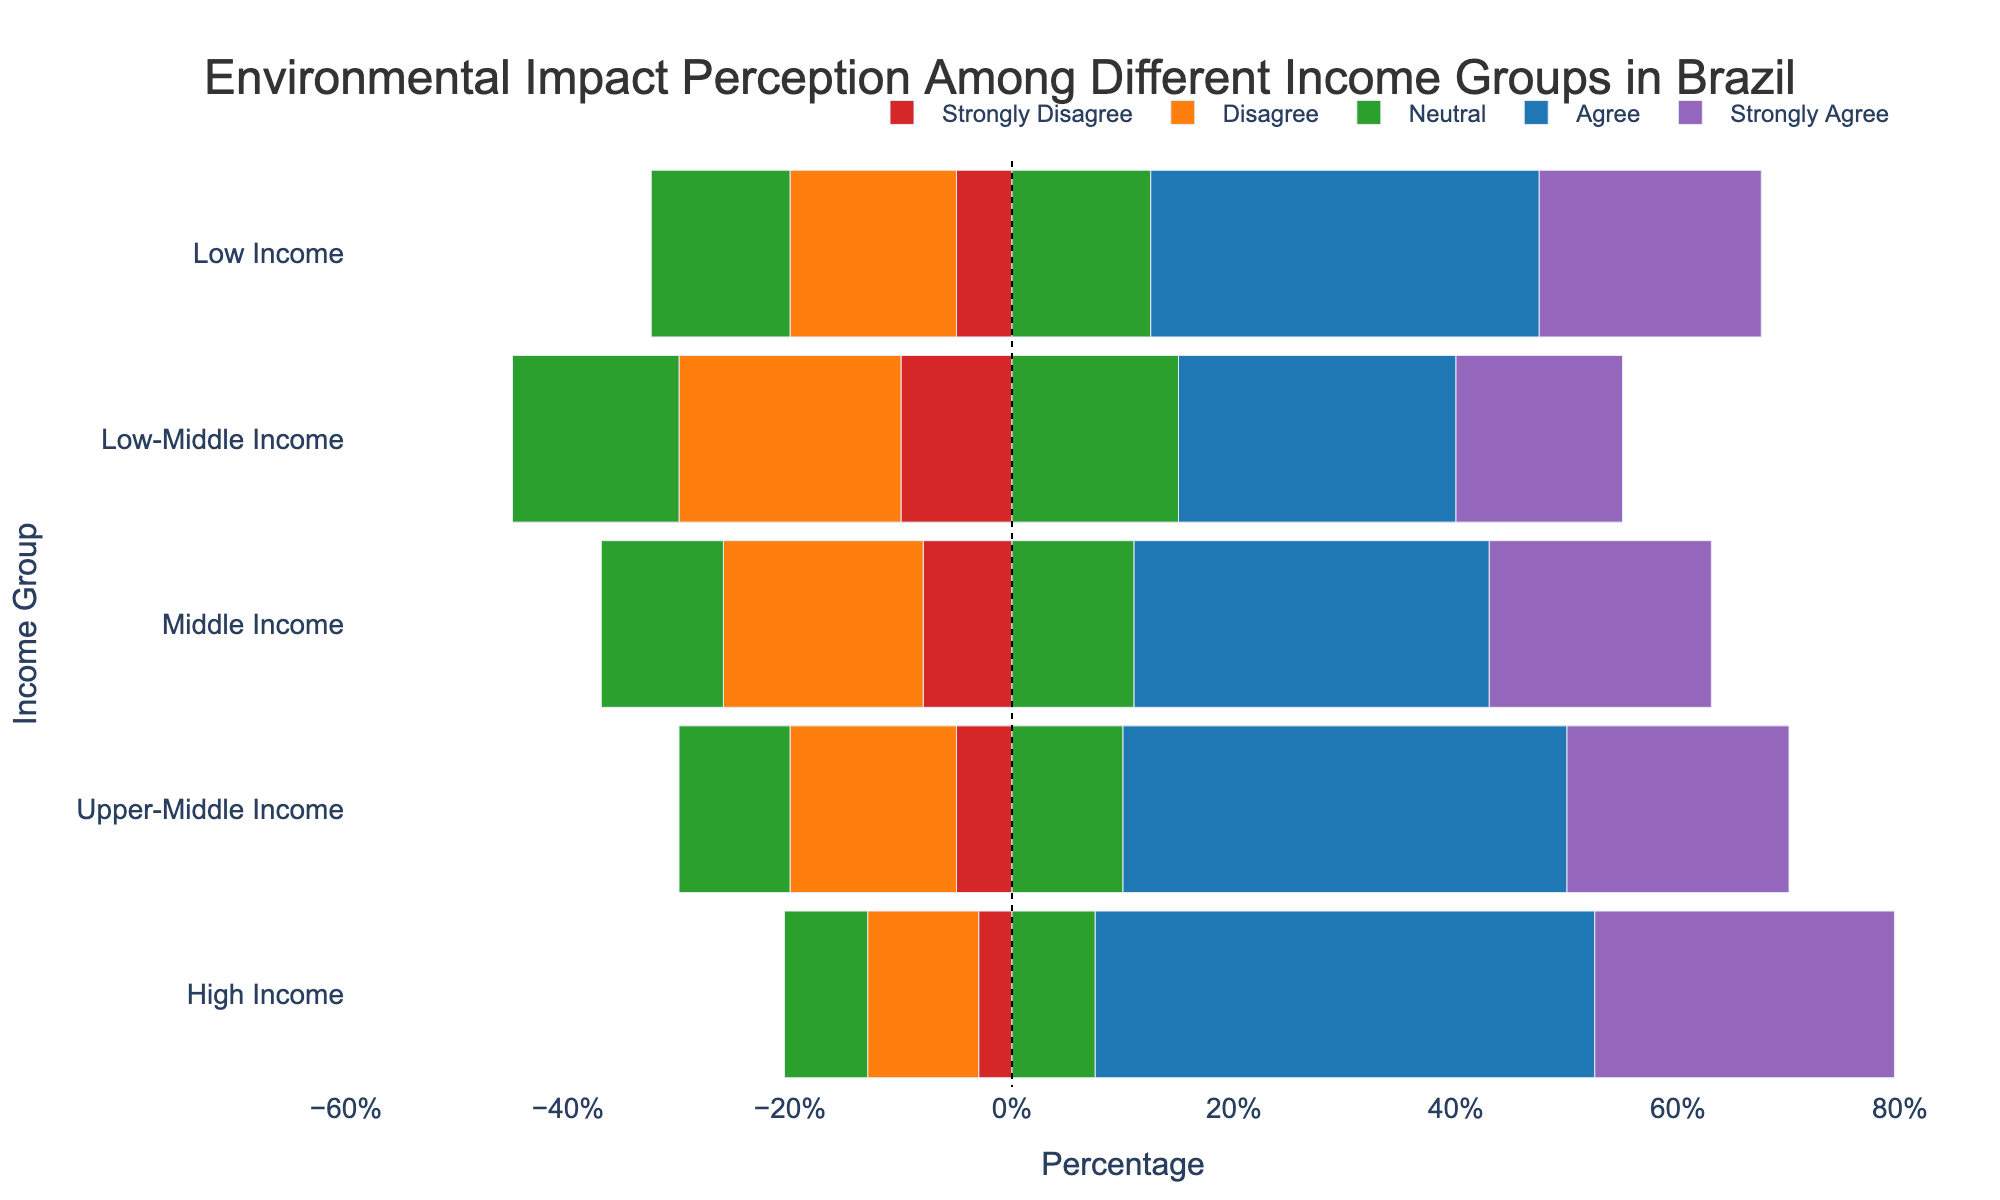Which income group has the highest percentage of people who 'Strongly Agree' on environmental impact? To determine this, look for the group with the longest bar segment in the 'Strongly Agree' section (blue color). The High Income group shows the longest 'Strongly Agree' bar.
Answer: High Income How many more people in the High Income group 'Agree' with the environmental impact compared to the Low Income group? Look at the length of the 'Agree' segments (light blue color) for both groups. The High Income group has 45% in 'Agree', whereas the Low Income group has 35%. Subtract 35% from 45% to get 10%.
Answer: 10% What is the total percentage of Low-Middle Income group people who either 'Agree' or 'Strongly Agree' on environmental impact? Sum the 'Agree' and 'Strongly Agree' percentages for the Low-Middle Income group. They are 25% and 15%, respectively. Adding them gives 25% + 15% = 40%.
Answer: 40% Which income group expresses the most disagreement (combination of 'Strongly Disagree' and 'Disagree')? Combine the 'Strongly Disagree' and 'Disagree' segments (red and orange colors) for each income group and compare them. The Low-Middle Income group has the highest total disagreement (10% + 20% = 30%).
Answer: Low-Middle Income How does the percentage of neutral responses in the Middle Income group compare to that in the Upper-Middle Income group? Look at the length of the 'Neutral' segments (green color) for both groups. Middle Income has 22% and Upper-Middle Income has 20%. Therefore, the Middle Income group has 2% more neutral responses than the Upper-Middle Income group.
Answer: Middle Income has 2% more neutral responses Which income group shows the highest combined percentage in the two top positive categories (‘Agree’ and ‘Strongly Agree’)? Combine the 'Agree' and 'Strongly Agree' segments for each group and find the maximum. The High Income group has the highest combined percentage with (45% + 27% = 72%).
Answer: High Income What is the combined percentage of negative and positive responses for Upper-Middle Income group? Sum the 'Strongly Disagree' and 'Disagree' percentages (negative) and 'Agree' and 'Strongly Agree' percentages (positive). The negative responses are 5% + 15% = 20%, and positive responses are 40% + 20% = 60%. Combined percentage is 20% + 60% = 80%.
Answer: 80% Which income group has the smallest proportion of strongly negative responses ('Strongly Disagree')? Look at the 'Strongly Disagree' segments (red color). High Income group has the smallest proportion at 3%.
Answer: High Income By how much does the 'Neutral' response in the Low Income group exceed that in the High Income group? Look at the 'Neutral' segments (green color) for both groups. Low Income has 25% and High Income has 15%. Subtract to find the difference: 25% - 15% = 10%.
Answer: 10% 